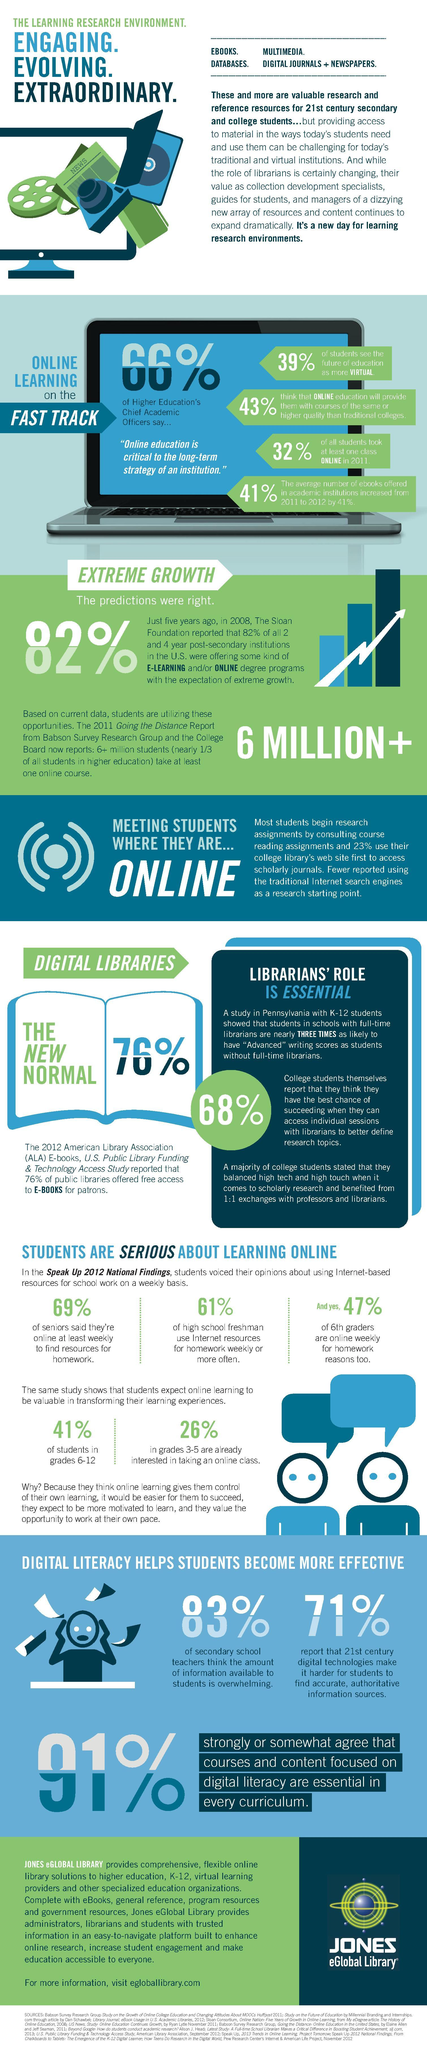What percent of students in grades 3-5 are already interested in taking an online class according to the study?
Answer the question with a short phrase. 25% What percentage of all students took at least one online class in 2011? 32% What percent of high school freshman use internet resources for homework weekly or more often according to the study? 61% What percent of the secondary school teachers think that the amount of information available to students in digital form is overwhelming as per the study? 83% What percentage of the students in grades 6-12 expect online learning to be valuable in transforming their learning experience as per the study? 41% 